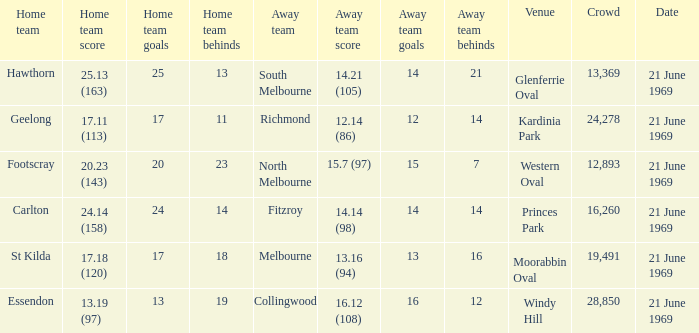When did an away team score 15.7 (97)? 21 June 1969. 